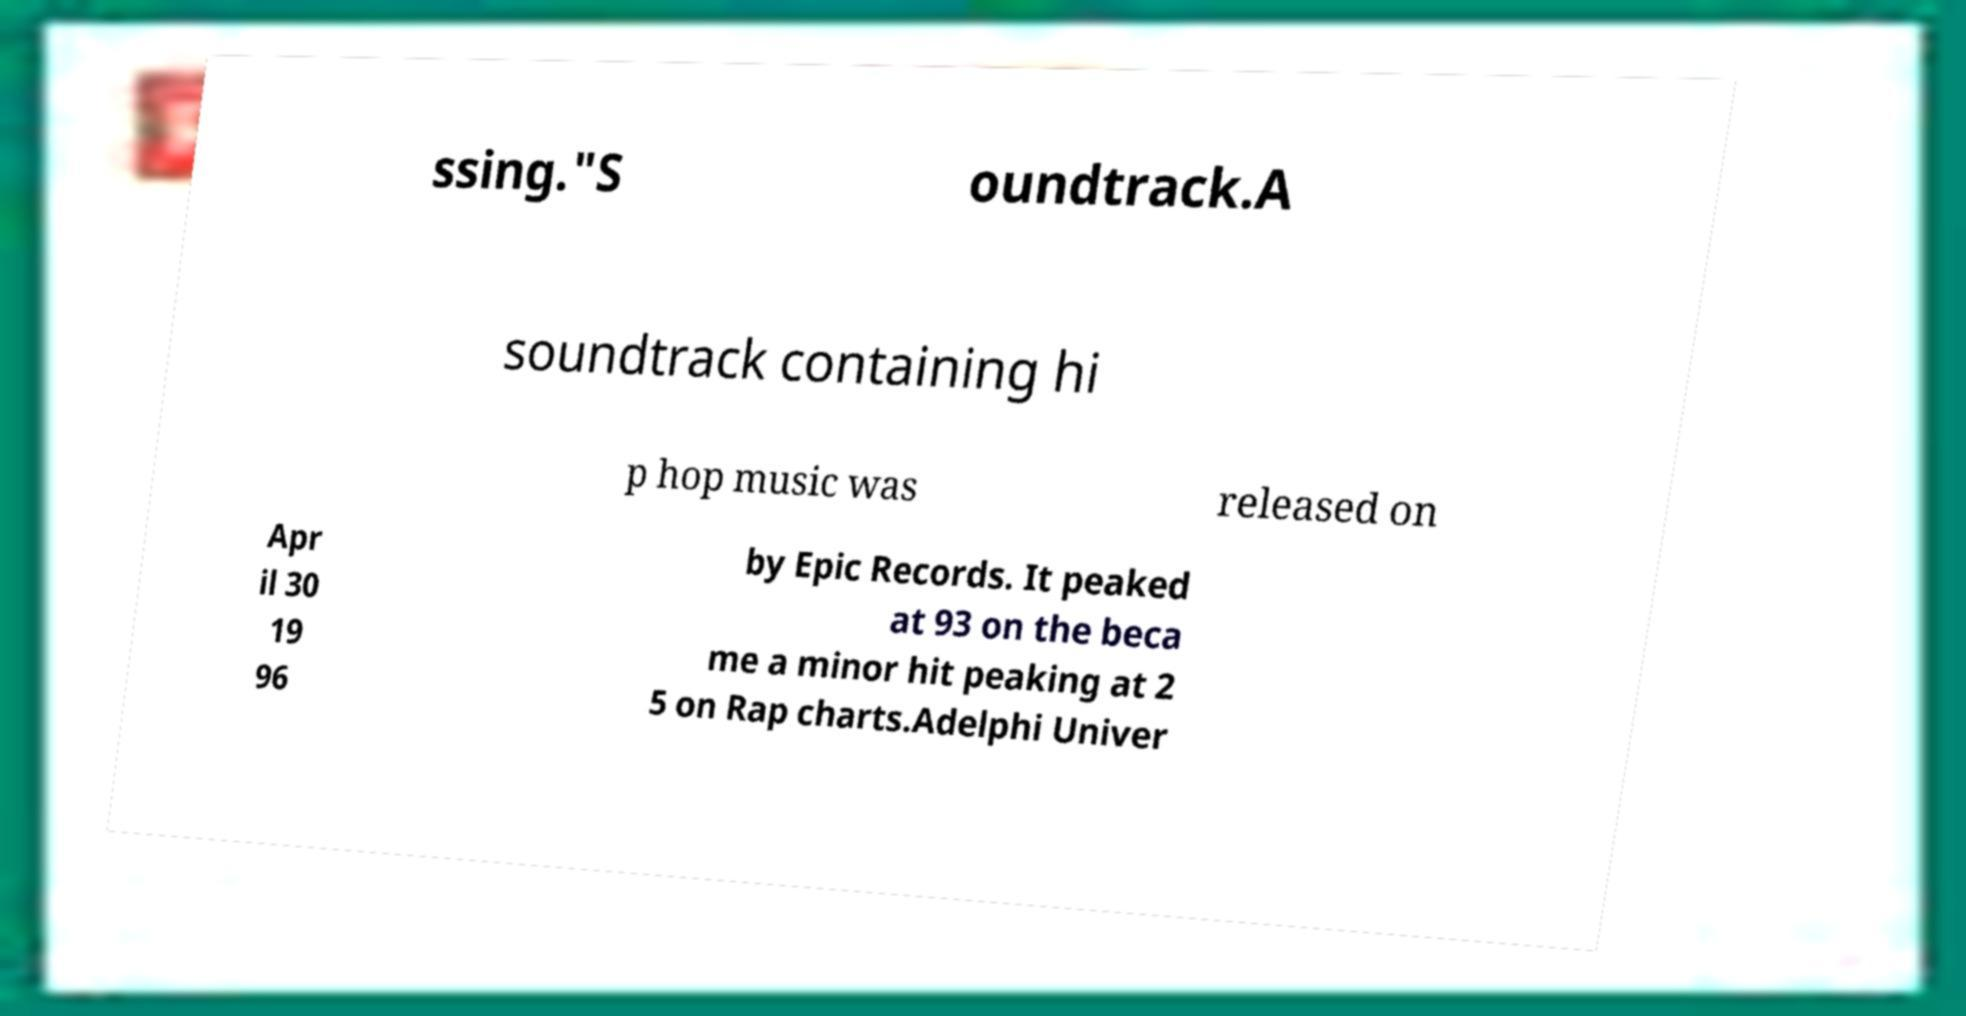Could you assist in decoding the text presented in this image and type it out clearly? ssing."S oundtrack.A soundtrack containing hi p hop music was released on Apr il 30 19 96 by Epic Records. It peaked at 93 on the beca me a minor hit peaking at 2 5 on Rap charts.Adelphi Univer 